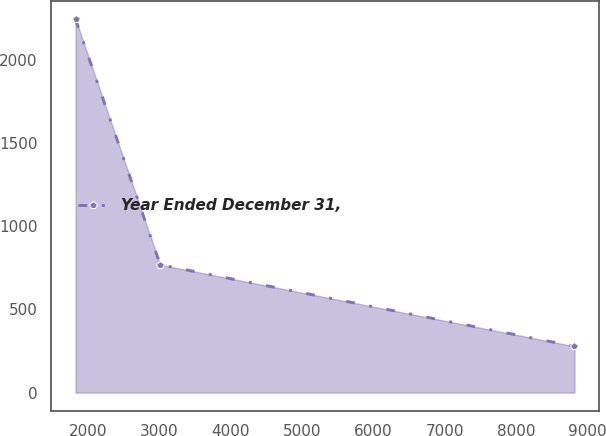<chart> <loc_0><loc_0><loc_500><loc_500><line_chart><ecel><fcel>Year Ended December 31,<nl><fcel>1830.04<fcel>2243.3<nl><fcel>3016.49<fcel>768.36<nl><fcel>8820.56<fcel>278.24<nl></chart> 